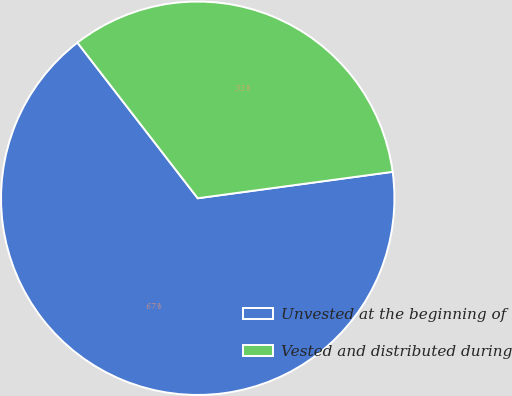<chart> <loc_0><loc_0><loc_500><loc_500><pie_chart><fcel>Unvested at the beginning of<fcel>Vested and distributed during<nl><fcel>66.67%<fcel>33.33%<nl></chart> 